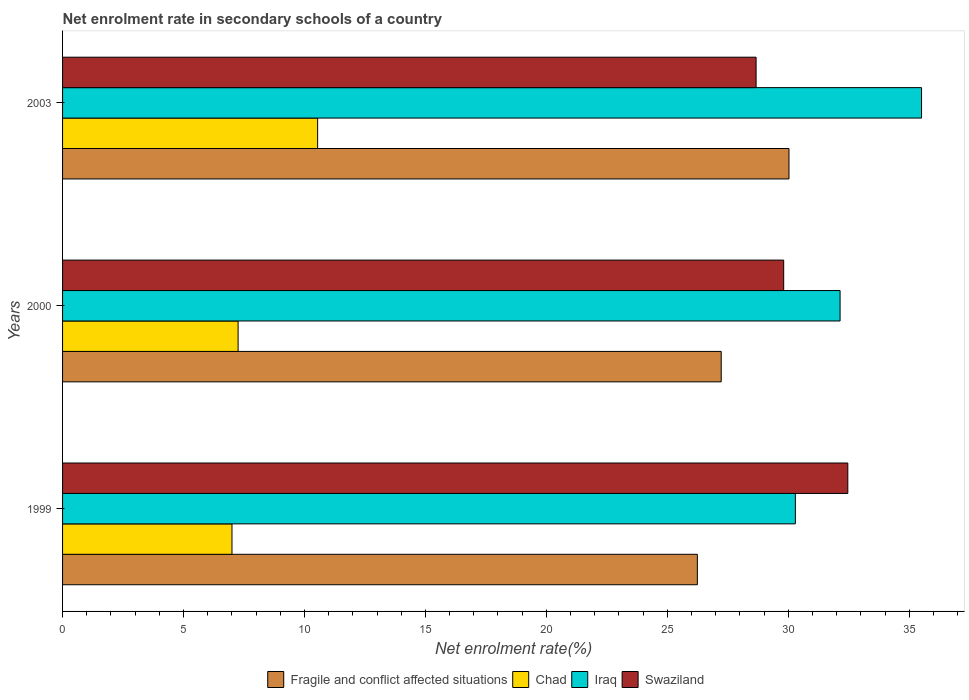How many groups of bars are there?
Offer a terse response. 3. How many bars are there on the 2nd tick from the bottom?
Provide a short and direct response. 4. What is the net enrolment rate in secondary schools in Swaziland in 1999?
Provide a short and direct response. 32.46. Across all years, what is the maximum net enrolment rate in secondary schools in Swaziland?
Provide a succinct answer. 32.46. Across all years, what is the minimum net enrolment rate in secondary schools in Chad?
Your answer should be compact. 7. In which year was the net enrolment rate in secondary schools in Iraq maximum?
Give a very brief answer. 2003. What is the total net enrolment rate in secondary schools in Fragile and conflict affected situations in the graph?
Your response must be concise. 83.5. What is the difference between the net enrolment rate in secondary schools in Swaziland in 2000 and that in 2003?
Your answer should be compact. 1.14. What is the difference between the net enrolment rate in secondary schools in Swaziland in 2000 and the net enrolment rate in secondary schools in Iraq in 2003?
Your response must be concise. -5.7. What is the average net enrolment rate in secondary schools in Iraq per year?
Your answer should be compact. 32.65. In the year 1999, what is the difference between the net enrolment rate in secondary schools in Chad and net enrolment rate in secondary schools in Fragile and conflict affected situations?
Your response must be concise. -19.24. In how many years, is the net enrolment rate in secondary schools in Chad greater than 7 %?
Keep it short and to the point. 3. What is the ratio of the net enrolment rate in secondary schools in Fragile and conflict affected situations in 1999 to that in 2003?
Give a very brief answer. 0.87. Is the net enrolment rate in secondary schools in Chad in 1999 less than that in 2000?
Your answer should be compact. Yes. What is the difference between the highest and the second highest net enrolment rate in secondary schools in Iraq?
Your answer should be very brief. 3.37. What is the difference between the highest and the lowest net enrolment rate in secondary schools in Chad?
Ensure brevity in your answer.  3.54. In how many years, is the net enrolment rate in secondary schools in Swaziland greater than the average net enrolment rate in secondary schools in Swaziland taken over all years?
Give a very brief answer. 1. What does the 4th bar from the top in 2003 represents?
Your answer should be very brief. Fragile and conflict affected situations. What does the 4th bar from the bottom in 2000 represents?
Your answer should be very brief. Swaziland. Is it the case that in every year, the sum of the net enrolment rate in secondary schools in Fragile and conflict affected situations and net enrolment rate in secondary schools in Chad is greater than the net enrolment rate in secondary schools in Swaziland?
Keep it short and to the point. Yes. Are all the bars in the graph horizontal?
Ensure brevity in your answer.  Yes. How many years are there in the graph?
Provide a succinct answer. 3. What is the difference between two consecutive major ticks on the X-axis?
Provide a succinct answer. 5. Does the graph contain any zero values?
Ensure brevity in your answer.  No. Where does the legend appear in the graph?
Keep it short and to the point. Bottom center. How many legend labels are there?
Your answer should be very brief. 4. How are the legend labels stacked?
Give a very brief answer. Horizontal. What is the title of the graph?
Provide a short and direct response. Net enrolment rate in secondary schools of a country. What is the label or title of the X-axis?
Give a very brief answer. Net enrolment rate(%). What is the Net enrolment rate(%) in Fragile and conflict affected situations in 1999?
Ensure brevity in your answer.  26.24. What is the Net enrolment rate(%) in Chad in 1999?
Your answer should be very brief. 7. What is the Net enrolment rate(%) in Iraq in 1999?
Make the answer very short. 30.29. What is the Net enrolment rate(%) of Swaziland in 1999?
Your answer should be very brief. 32.46. What is the Net enrolment rate(%) in Fragile and conflict affected situations in 2000?
Your answer should be very brief. 27.23. What is the Net enrolment rate(%) in Chad in 2000?
Ensure brevity in your answer.  7.26. What is the Net enrolment rate(%) in Iraq in 2000?
Your answer should be very brief. 32.14. What is the Net enrolment rate(%) of Swaziland in 2000?
Provide a short and direct response. 29.81. What is the Net enrolment rate(%) in Fragile and conflict affected situations in 2003?
Your answer should be compact. 30.03. What is the Net enrolment rate(%) in Chad in 2003?
Keep it short and to the point. 10.54. What is the Net enrolment rate(%) of Iraq in 2003?
Offer a very short reply. 35.51. What is the Net enrolment rate(%) of Swaziland in 2003?
Offer a terse response. 28.67. Across all years, what is the maximum Net enrolment rate(%) of Fragile and conflict affected situations?
Make the answer very short. 30.03. Across all years, what is the maximum Net enrolment rate(%) in Chad?
Offer a terse response. 10.54. Across all years, what is the maximum Net enrolment rate(%) of Iraq?
Your answer should be compact. 35.51. Across all years, what is the maximum Net enrolment rate(%) of Swaziland?
Make the answer very short. 32.46. Across all years, what is the minimum Net enrolment rate(%) in Fragile and conflict affected situations?
Offer a terse response. 26.24. Across all years, what is the minimum Net enrolment rate(%) in Chad?
Your answer should be very brief. 7. Across all years, what is the minimum Net enrolment rate(%) in Iraq?
Your answer should be compact. 30.29. Across all years, what is the minimum Net enrolment rate(%) of Swaziland?
Your response must be concise. 28.67. What is the total Net enrolment rate(%) in Fragile and conflict affected situations in the graph?
Make the answer very short. 83.5. What is the total Net enrolment rate(%) of Chad in the graph?
Provide a succinct answer. 24.8. What is the total Net enrolment rate(%) in Iraq in the graph?
Offer a very short reply. 97.95. What is the total Net enrolment rate(%) in Swaziland in the graph?
Your answer should be compact. 90.94. What is the difference between the Net enrolment rate(%) of Fragile and conflict affected situations in 1999 and that in 2000?
Provide a short and direct response. -0.99. What is the difference between the Net enrolment rate(%) in Chad in 1999 and that in 2000?
Make the answer very short. -0.25. What is the difference between the Net enrolment rate(%) of Iraq in 1999 and that in 2000?
Ensure brevity in your answer.  -1.85. What is the difference between the Net enrolment rate(%) of Swaziland in 1999 and that in 2000?
Your answer should be compact. 2.65. What is the difference between the Net enrolment rate(%) in Fragile and conflict affected situations in 1999 and that in 2003?
Ensure brevity in your answer.  -3.79. What is the difference between the Net enrolment rate(%) of Chad in 1999 and that in 2003?
Make the answer very short. -3.54. What is the difference between the Net enrolment rate(%) of Iraq in 1999 and that in 2003?
Make the answer very short. -5.22. What is the difference between the Net enrolment rate(%) in Swaziland in 1999 and that in 2003?
Make the answer very short. 3.79. What is the difference between the Net enrolment rate(%) of Fragile and conflict affected situations in 2000 and that in 2003?
Provide a short and direct response. -2.8. What is the difference between the Net enrolment rate(%) of Chad in 2000 and that in 2003?
Offer a terse response. -3.29. What is the difference between the Net enrolment rate(%) of Iraq in 2000 and that in 2003?
Offer a terse response. -3.37. What is the difference between the Net enrolment rate(%) in Swaziland in 2000 and that in 2003?
Your answer should be very brief. 1.14. What is the difference between the Net enrolment rate(%) of Fragile and conflict affected situations in 1999 and the Net enrolment rate(%) of Chad in 2000?
Your answer should be compact. 18.99. What is the difference between the Net enrolment rate(%) in Fragile and conflict affected situations in 1999 and the Net enrolment rate(%) in Iraq in 2000?
Provide a succinct answer. -5.9. What is the difference between the Net enrolment rate(%) in Fragile and conflict affected situations in 1999 and the Net enrolment rate(%) in Swaziland in 2000?
Make the answer very short. -3.57. What is the difference between the Net enrolment rate(%) in Chad in 1999 and the Net enrolment rate(%) in Iraq in 2000?
Provide a succinct answer. -25.14. What is the difference between the Net enrolment rate(%) in Chad in 1999 and the Net enrolment rate(%) in Swaziland in 2000?
Ensure brevity in your answer.  -22.81. What is the difference between the Net enrolment rate(%) of Iraq in 1999 and the Net enrolment rate(%) of Swaziland in 2000?
Your response must be concise. 0.48. What is the difference between the Net enrolment rate(%) of Fragile and conflict affected situations in 1999 and the Net enrolment rate(%) of Chad in 2003?
Offer a terse response. 15.7. What is the difference between the Net enrolment rate(%) in Fragile and conflict affected situations in 1999 and the Net enrolment rate(%) in Iraq in 2003?
Your answer should be very brief. -9.27. What is the difference between the Net enrolment rate(%) in Fragile and conflict affected situations in 1999 and the Net enrolment rate(%) in Swaziland in 2003?
Provide a succinct answer. -2.43. What is the difference between the Net enrolment rate(%) of Chad in 1999 and the Net enrolment rate(%) of Iraq in 2003?
Your answer should be very brief. -28.51. What is the difference between the Net enrolment rate(%) of Chad in 1999 and the Net enrolment rate(%) of Swaziland in 2003?
Ensure brevity in your answer.  -21.67. What is the difference between the Net enrolment rate(%) of Iraq in 1999 and the Net enrolment rate(%) of Swaziland in 2003?
Provide a short and direct response. 1.62. What is the difference between the Net enrolment rate(%) in Fragile and conflict affected situations in 2000 and the Net enrolment rate(%) in Chad in 2003?
Offer a terse response. 16.68. What is the difference between the Net enrolment rate(%) in Fragile and conflict affected situations in 2000 and the Net enrolment rate(%) in Iraq in 2003?
Provide a succinct answer. -8.28. What is the difference between the Net enrolment rate(%) in Fragile and conflict affected situations in 2000 and the Net enrolment rate(%) in Swaziland in 2003?
Give a very brief answer. -1.44. What is the difference between the Net enrolment rate(%) in Chad in 2000 and the Net enrolment rate(%) in Iraq in 2003?
Provide a succinct answer. -28.25. What is the difference between the Net enrolment rate(%) of Chad in 2000 and the Net enrolment rate(%) of Swaziland in 2003?
Your response must be concise. -21.41. What is the difference between the Net enrolment rate(%) in Iraq in 2000 and the Net enrolment rate(%) in Swaziland in 2003?
Provide a short and direct response. 3.47. What is the average Net enrolment rate(%) in Fragile and conflict affected situations per year?
Offer a very short reply. 27.83. What is the average Net enrolment rate(%) of Chad per year?
Keep it short and to the point. 8.27. What is the average Net enrolment rate(%) of Iraq per year?
Keep it short and to the point. 32.65. What is the average Net enrolment rate(%) of Swaziland per year?
Offer a very short reply. 30.31. In the year 1999, what is the difference between the Net enrolment rate(%) in Fragile and conflict affected situations and Net enrolment rate(%) in Chad?
Offer a terse response. 19.24. In the year 1999, what is the difference between the Net enrolment rate(%) of Fragile and conflict affected situations and Net enrolment rate(%) of Iraq?
Give a very brief answer. -4.05. In the year 1999, what is the difference between the Net enrolment rate(%) in Fragile and conflict affected situations and Net enrolment rate(%) in Swaziland?
Offer a terse response. -6.22. In the year 1999, what is the difference between the Net enrolment rate(%) of Chad and Net enrolment rate(%) of Iraq?
Ensure brevity in your answer.  -23.29. In the year 1999, what is the difference between the Net enrolment rate(%) of Chad and Net enrolment rate(%) of Swaziland?
Give a very brief answer. -25.46. In the year 1999, what is the difference between the Net enrolment rate(%) of Iraq and Net enrolment rate(%) of Swaziland?
Give a very brief answer. -2.17. In the year 2000, what is the difference between the Net enrolment rate(%) in Fragile and conflict affected situations and Net enrolment rate(%) in Chad?
Make the answer very short. 19.97. In the year 2000, what is the difference between the Net enrolment rate(%) of Fragile and conflict affected situations and Net enrolment rate(%) of Iraq?
Provide a short and direct response. -4.91. In the year 2000, what is the difference between the Net enrolment rate(%) of Fragile and conflict affected situations and Net enrolment rate(%) of Swaziland?
Give a very brief answer. -2.58. In the year 2000, what is the difference between the Net enrolment rate(%) in Chad and Net enrolment rate(%) in Iraq?
Provide a short and direct response. -24.89. In the year 2000, what is the difference between the Net enrolment rate(%) in Chad and Net enrolment rate(%) in Swaziland?
Your answer should be very brief. -22.55. In the year 2000, what is the difference between the Net enrolment rate(%) of Iraq and Net enrolment rate(%) of Swaziland?
Your answer should be compact. 2.33. In the year 2003, what is the difference between the Net enrolment rate(%) in Fragile and conflict affected situations and Net enrolment rate(%) in Chad?
Your answer should be compact. 19.49. In the year 2003, what is the difference between the Net enrolment rate(%) of Fragile and conflict affected situations and Net enrolment rate(%) of Iraq?
Ensure brevity in your answer.  -5.48. In the year 2003, what is the difference between the Net enrolment rate(%) of Fragile and conflict affected situations and Net enrolment rate(%) of Swaziland?
Ensure brevity in your answer.  1.36. In the year 2003, what is the difference between the Net enrolment rate(%) of Chad and Net enrolment rate(%) of Iraq?
Make the answer very short. -24.97. In the year 2003, what is the difference between the Net enrolment rate(%) of Chad and Net enrolment rate(%) of Swaziland?
Make the answer very short. -18.13. In the year 2003, what is the difference between the Net enrolment rate(%) of Iraq and Net enrolment rate(%) of Swaziland?
Offer a very short reply. 6.84. What is the ratio of the Net enrolment rate(%) of Fragile and conflict affected situations in 1999 to that in 2000?
Offer a terse response. 0.96. What is the ratio of the Net enrolment rate(%) of Chad in 1999 to that in 2000?
Provide a succinct answer. 0.97. What is the ratio of the Net enrolment rate(%) in Iraq in 1999 to that in 2000?
Give a very brief answer. 0.94. What is the ratio of the Net enrolment rate(%) in Swaziland in 1999 to that in 2000?
Ensure brevity in your answer.  1.09. What is the ratio of the Net enrolment rate(%) in Fragile and conflict affected situations in 1999 to that in 2003?
Your answer should be very brief. 0.87. What is the ratio of the Net enrolment rate(%) of Chad in 1999 to that in 2003?
Provide a succinct answer. 0.66. What is the ratio of the Net enrolment rate(%) in Iraq in 1999 to that in 2003?
Your answer should be very brief. 0.85. What is the ratio of the Net enrolment rate(%) of Swaziland in 1999 to that in 2003?
Ensure brevity in your answer.  1.13. What is the ratio of the Net enrolment rate(%) of Fragile and conflict affected situations in 2000 to that in 2003?
Ensure brevity in your answer.  0.91. What is the ratio of the Net enrolment rate(%) in Chad in 2000 to that in 2003?
Ensure brevity in your answer.  0.69. What is the ratio of the Net enrolment rate(%) of Iraq in 2000 to that in 2003?
Your answer should be compact. 0.91. What is the ratio of the Net enrolment rate(%) in Swaziland in 2000 to that in 2003?
Make the answer very short. 1.04. What is the difference between the highest and the second highest Net enrolment rate(%) of Fragile and conflict affected situations?
Provide a succinct answer. 2.8. What is the difference between the highest and the second highest Net enrolment rate(%) in Chad?
Ensure brevity in your answer.  3.29. What is the difference between the highest and the second highest Net enrolment rate(%) of Iraq?
Offer a very short reply. 3.37. What is the difference between the highest and the second highest Net enrolment rate(%) in Swaziland?
Offer a terse response. 2.65. What is the difference between the highest and the lowest Net enrolment rate(%) of Fragile and conflict affected situations?
Provide a short and direct response. 3.79. What is the difference between the highest and the lowest Net enrolment rate(%) of Chad?
Provide a short and direct response. 3.54. What is the difference between the highest and the lowest Net enrolment rate(%) of Iraq?
Your answer should be very brief. 5.22. What is the difference between the highest and the lowest Net enrolment rate(%) of Swaziland?
Ensure brevity in your answer.  3.79. 